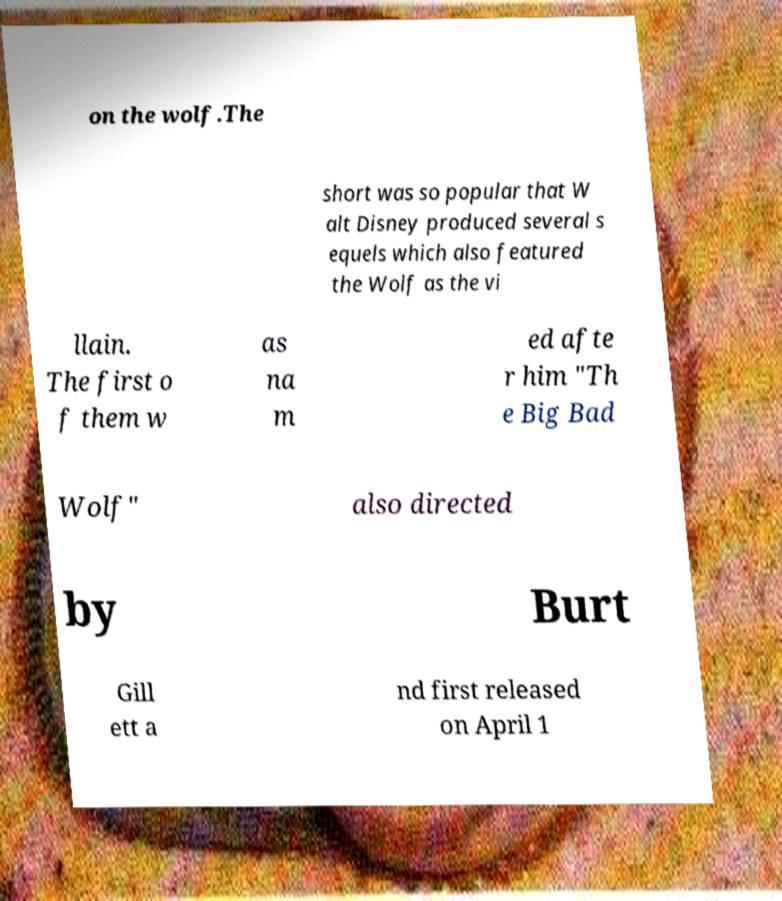Could you assist in decoding the text presented in this image and type it out clearly? on the wolf.The short was so popular that W alt Disney produced several s equels which also featured the Wolf as the vi llain. The first o f them w as na m ed afte r him "Th e Big Bad Wolf" also directed by Burt Gill ett a nd first released on April 1 